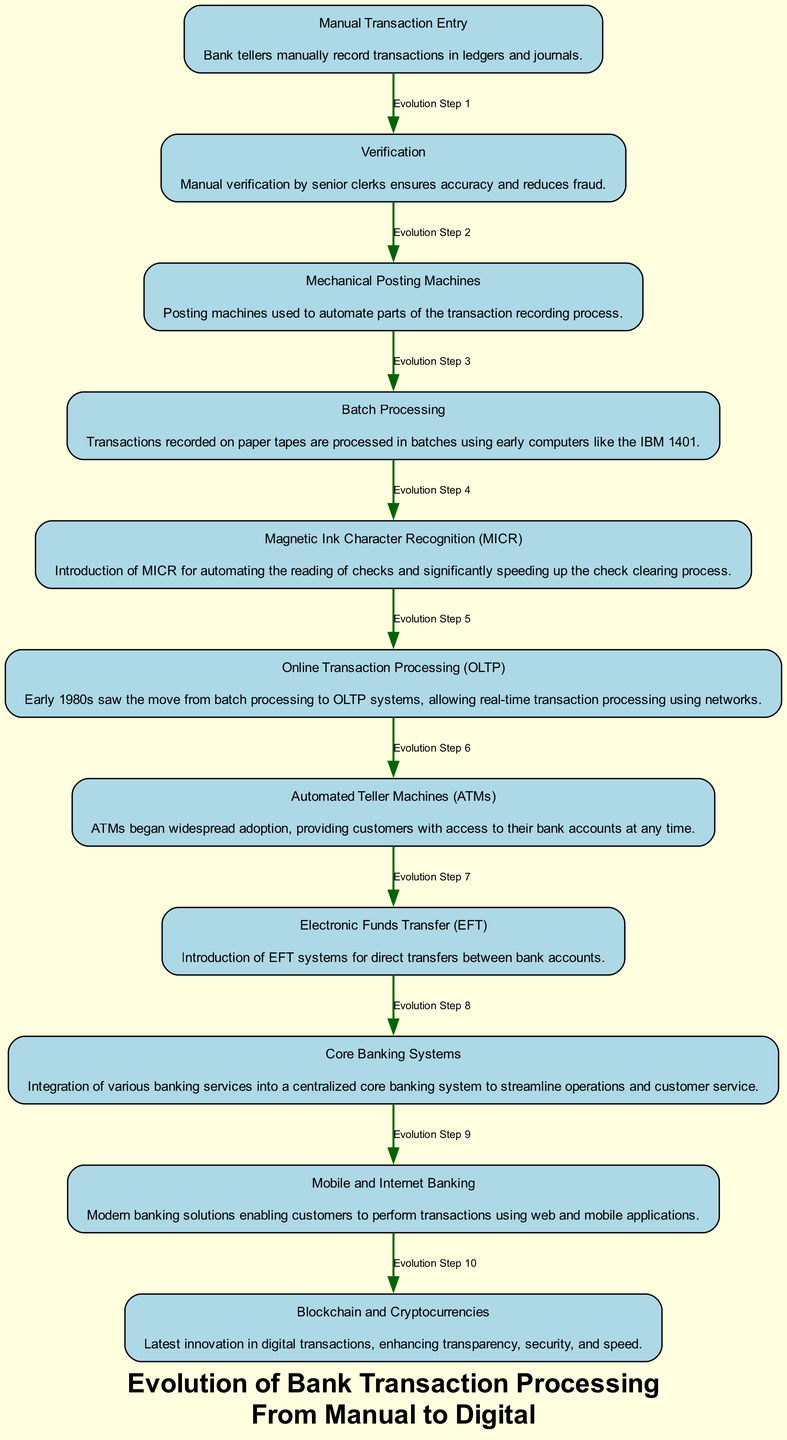What is the first step in the evolution of bank transaction processing? The diagram indicates that the first step is "Manual Transaction Entry," where bank tellers manually record transactions.
Answer: Manual Transaction Entry How many steps are depicted in the diagram? By counting the nodes listed in the diagram, we find there are 11 distinct steps or elements shown.
Answer: 11 What is the last step in the process? The final step mentioned in the diagram is "Blockchain and Cryptocurrencies," indicating the latest innovation in digital transactions.
Answer: Blockchain and Cryptocurrencies What process followed "Mechanical Posting Machines"? Looking at the diagram, "Batch Processing" comes after "Mechanical Posting Machines," showing the evolution from mechanical to batch processing systems.
Answer: Batch Processing Which transaction processing method began widespread adoption in the 1980s? The diagram specifies that "Online Transaction Processing (OLTP)" marks the transition to real-time transaction processing in this period.
Answer: Online Transaction Processing (OLTP) What technology was introduced for automating the reading of checks? The diagram points out that "Magnetic Ink Character Recognition (MICR)" was introduced to significantly improve the check clearing process.
Answer: Magnetic Ink Character Recognition (MICR) Which elements correspond to customer-facing services? Evaluating the diagram, both "Automated Teller Machines (ATMs)" and "Mobile and Internet Banking" are designed to provide customer access to banking services.
Answer: Automated Teller Machines and Mobile and Internet Banking What is the relationship between "Electronic Funds Transfer (EFT)" and "Core Banking Systems"? The diagram presents a flow where "Electronic Funds Transfer (EFT)" leads to the development of centralized "Core Banking Systems," indicating modernization in banking service integration.
Answer: EFT leads to Core Banking Systems What major milestone occurred before the introduction of ATMs? According to the diagram, the milestone preceding "Automated Teller Machines (ATMs)" is "Online Transaction Processing (OLTP)," showcasing a critical transition in bank transaction methods.
Answer: Online Transaction Processing (OLTP) What innovation is regarded as the latest in digital transactions? The diagram concludes with "Blockchain and Cryptocurrencies," highlighting this as the newest advancement in banking transaction technology.
Answer: Blockchain and Cryptocurrencies 